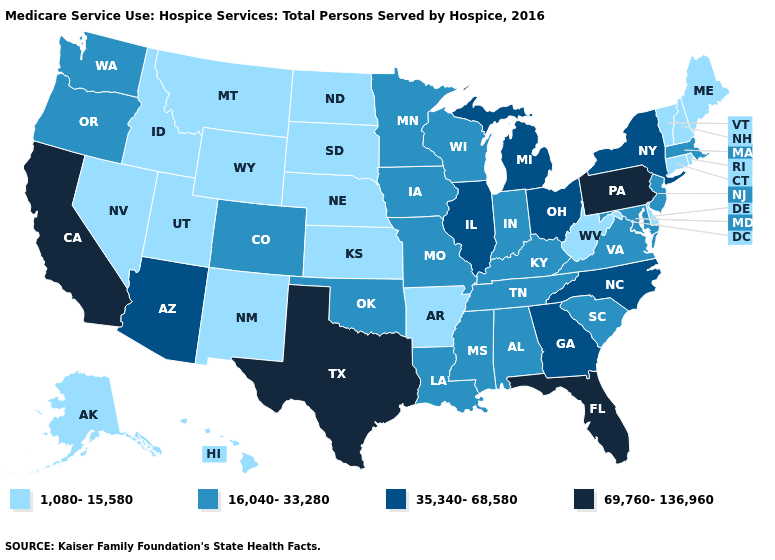What is the highest value in the USA?
Keep it brief. 69,760-136,960. Name the states that have a value in the range 1,080-15,580?
Quick response, please. Alaska, Arkansas, Connecticut, Delaware, Hawaii, Idaho, Kansas, Maine, Montana, Nebraska, Nevada, New Hampshire, New Mexico, North Dakota, Rhode Island, South Dakota, Utah, Vermont, West Virginia, Wyoming. What is the highest value in the USA?
Give a very brief answer. 69,760-136,960. Which states have the highest value in the USA?
Write a very short answer. California, Florida, Pennsylvania, Texas. What is the lowest value in the West?
Short answer required. 1,080-15,580. Does Nebraska have the same value as Arizona?
Keep it brief. No. What is the value of New Mexico?
Quick response, please. 1,080-15,580. Which states hav the highest value in the Northeast?
Concise answer only. Pennsylvania. Name the states that have a value in the range 35,340-68,580?
Give a very brief answer. Arizona, Georgia, Illinois, Michigan, New York, North Carolina, Ohio. What is the lowest value in the USA?
Quick response, please. 1,080-15,580. Does Delaware have the lowest value in the South?
Give a very brief answer. Yes. Among the states that border North Dakota , which have the lowest value?
Be succinct. Montana, South Dakota. Does the map have missing data?
Be succinct. No. How many symbols are there in the legend?
Give a very brief answer. 4. Does Florida have the lowest value in the USA?
Give a very brief answer. No. 